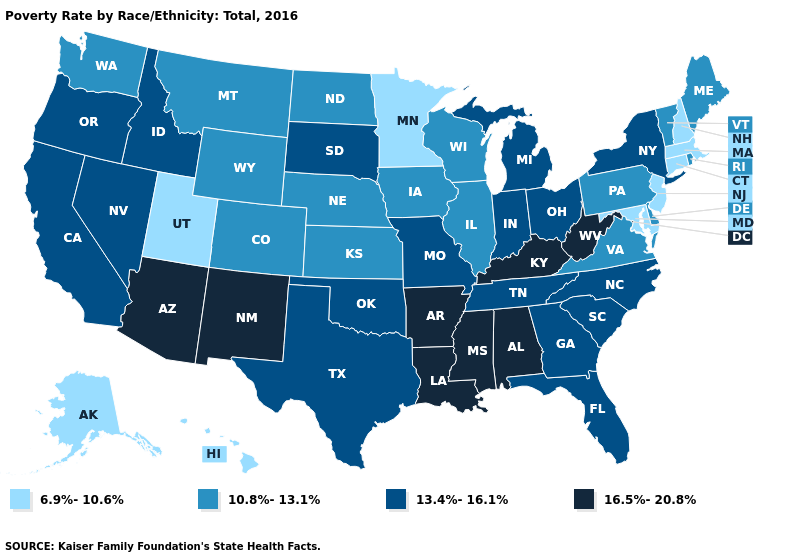What is the value of Kansas?
Give a very brief answer. 10.8%-13.1%. Does Kentucky have the highest value in the USA?
Be succinct. Yes. What is the value of West Virginia?
Quick response, please. 16.5%-20.8%. Does South Dakota have a higher value than Alaska?
Be succinct. Yes. How many symbols are there in the legend?
Answer briefly. 4. Among the states that border Tennessee , which have the lowest value?
Be succinct. Virginia. Is the legend a continuous bar?
Write a very short answer. No. Does Illinois have a higher value than New Jersey?
Keep it brief. Yes. Does New Hampshire have the lowest value in the Northeast?
Quick response, please. Yes. Among the states that border Kentucky , which have the highest value?
Write a very short answer. West Virginia. Does the first symbol in the legend represent the smallest category?
Short answer required. Yes. Which states have the highest value in the USA?
Short answer required. Alabama, Arizona, Arkansas, Kentucky, Louisiana, Mississippi, New Mexico, West Virginia. Name the states that have a value in the range 16.5%-20.8%?
Write a very short answer. Alabama, Arizona, Arkansas, Kentucky, Louisiana, Mississippi, New Mexico, West Virginia. What is the lowest value in the USA?
Quick response, please. 6.9%-10.6%. What is the value of Washington?
Concise answer only. 10.8%-13.1%. 